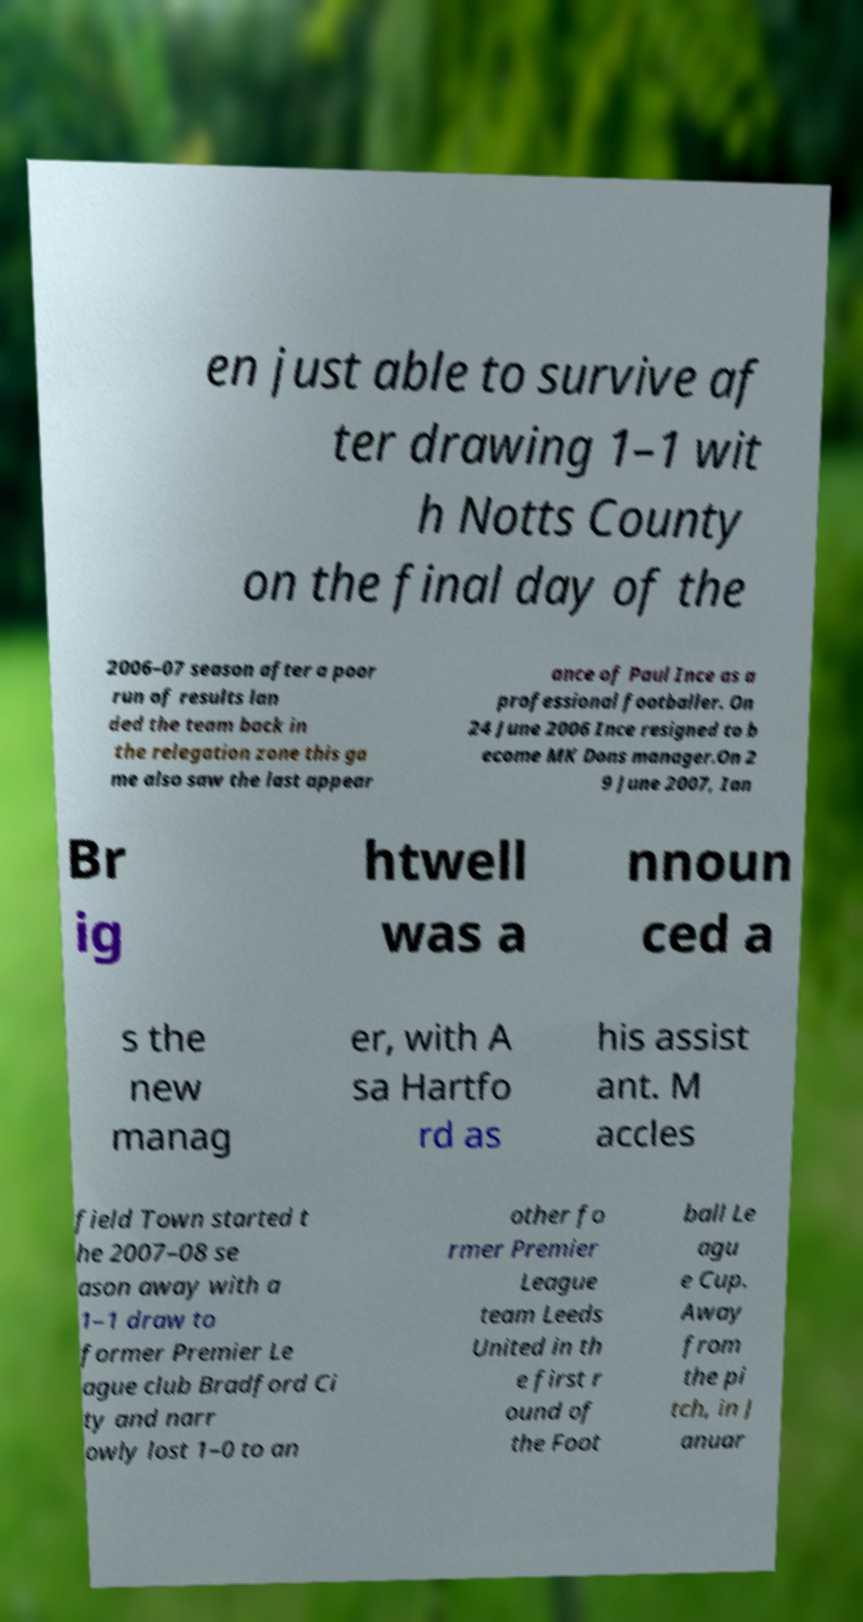For documentation purposes, I need the text within this image transcribed. Could you provide that? en just able to survive af ter drawing 1–1 wit h Notts County on the final day of the 2006–07 season after a poor run of results lan ded the team back in the relegation zone this ga me also saw the last appear ance of Paul Ince as a professional footballer. On 24 June 2006 Ince resigned to b ecome MK Dons manager.On 2 9 June 2007, Ian Br ig htwell was a nnoun ced a s the new manag er, with A sa Hartfo rd as his assist ant. M accles field Town started t he 2007–08 se ason away with a 1–1 draw to former Premier Le ague club Bradford Ci ty and narr owly lost 1–0 to an other fo rmer Premier League team Leeds United in th e first r ound of the Foot ball Le agu e Cup. Away from the pi tch, in J anuar 